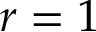<formula> <loc_0><loc_0><loc_500><loc_500>r = 1</formula> 